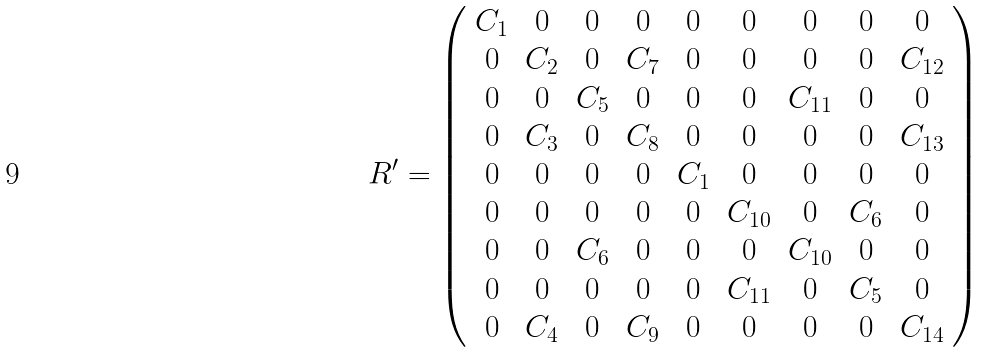<formula> <loc_0><loc_0><loc_500><loc_500>R ^ { \prime } = \left ( \begin{array} { c c c c c c c c c } C _ { 1 } & 0 & 0 & 0 & 0 & 0 & 0 & 0 & 0 \\ 0 & C _ { 2 } & 0 & C _ { 7 } & 0 & 0 & 0 & 0 & C _ { 1 2 } \\ 0 & 0 & C _ { 5 } & 0 & 0 & 0 & C _ { 1 1 } & 0 & 0 \\ 0 & C _ { 3 } & 0 & C _ { 8 } & 0 & 0 & 0 & 0 & C _ { 1 3 } \\ 0 & 0 & 0 & 0 & C _ { 1 } & 0 & 0 & 0 & 0 \\ 0 & 0 & 0 & 0 & 0 & C _ { 1 0 } & 0 & C _ { 6 } & 0 \\ 0 & 0 & C _ { 6 } & 0 & 0 & 0 & C _ { 1 0 } & 0 & 0 \\ 0 & 0 & 0 & 0 & 0 & C _ { 1 1 } & 0 & C _ { 5 } & 0 \\ 0 & C _ { 4 } & 0 & C _ { 9 } & 0 & 0 & 0 & 0 & C _ { 1 4 } \end{array} \right )</formula> 